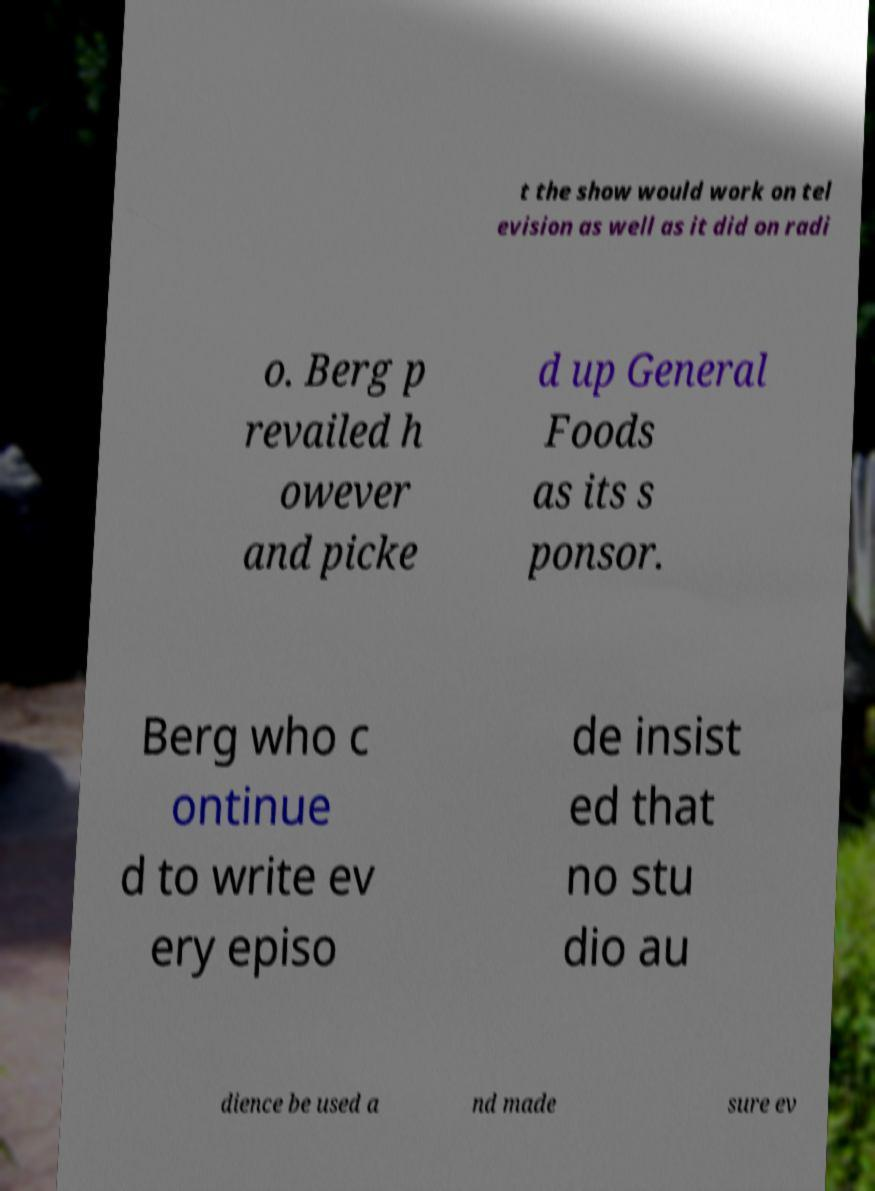Can you read and provide the text displayed in the image?This photo seems to have some interesting text. Can you extract and type it out for me? t the show would work on tel evision as well as it did on radi o. Berg p revailed h owever and picke d up General Foods as its s ponsor. Berg who c ontinue d to write ev ery episo de insist ed that no stu dio au dience be used a nd made sure ev 